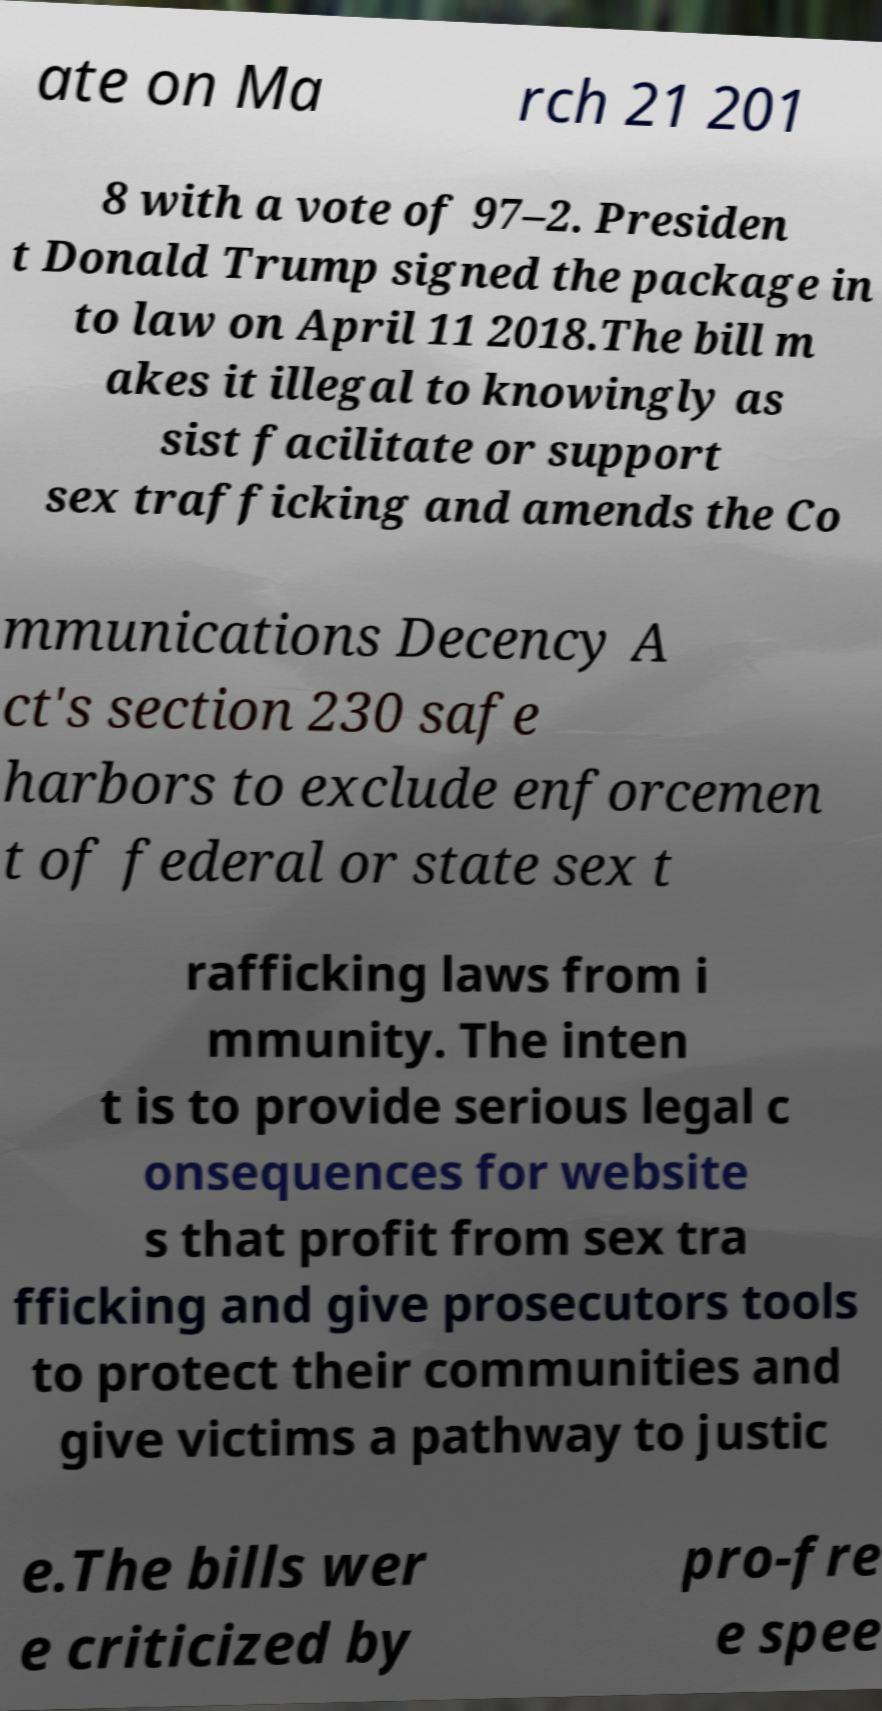There's text embedded in this image that I need extracted. Can you transcribe it verbatim? ate on Ma rch 21 201 8 with a vote of 97–2. Presiden t Donald Trump signed the package in to law on April 11 2018.The bill m akes it illegal to knowingly as sist facilitate or support sex trafficking and amends the Co mmunications Decency A ct's section 230 safe harbors to exclude enforcemen t of federal or state sex t rafficking laws from i mmunity. The inten t is to provide serious legal c onsequences for website s that profit from sex tra fficking and give prosecutors tools to protect their communities and give victims a pathway to justic e.The bills wer e criticized by pro-fre e spee 